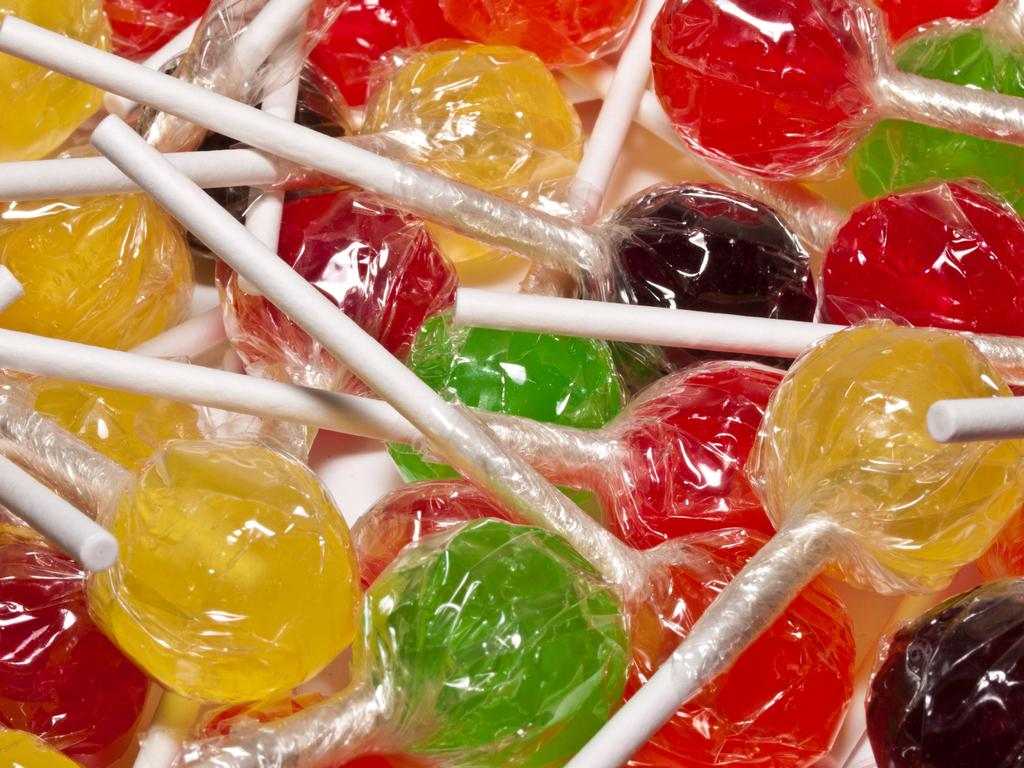What type of candy is featured in the image? There are colorful lollipops in the image. Can you describe the appearance of the lollipops? The lollipops are colorful, which suggests they come in various shades and hues. What type of metal is used to make the lollipop sticks in the image? The image does not provide information about the material used for the lollipop sticks, so it cannot be determined from the image. 